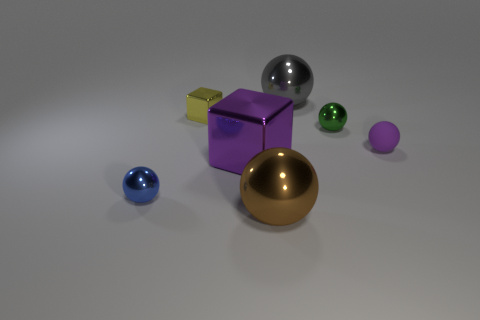Are there any small metallic things that have the same shape as the purple rubber thing?
Offer a terse response. Yes. There is a big brown object; is it the same shape as the green shiny thing that is to the right of the blue metal thing?
Your answer should be very brief. Yes. There is a object that is to the right of the tiny yellow block and to the left of the large brown shiny sphere; what size is it?
Your answer should be very brief. Large. What number of tiny green shiny cubes are there?
Your answer should be very brief. 0. There is a purple sphere that is the same size as the green shiny object; what is its material?
Keep it short and to the point. Rubber. Are there any green metallic balls of the same size as the brown metallic sphere?
Offer a very short reply. No. Do the metallic object behind the yellow block and the metallic cube in front of the small purple object have the same color?
Your response must be concise. No. What number of rubber things are tiny green objects or large blue objects?
Offer a very short reply. 0. There is a big sphere that is left of the large sphere on the right side of the brown metallic sphere; how many large objects are to the left of it?
Keep it short and to the point. 1. What is the size of the blue ball that is made of the same material as the tiny cube?
Provide a succinct answer. Small. 